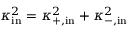Convert formula to latex. <formula><loc_0><loc_0><loc_500><loc_500>\kappa _ { i n } ^ { 2 } = \kappa _ { + , i n } ^ { 2 } + \kappa _ { - , i n } ^ { 2 }</formula> 